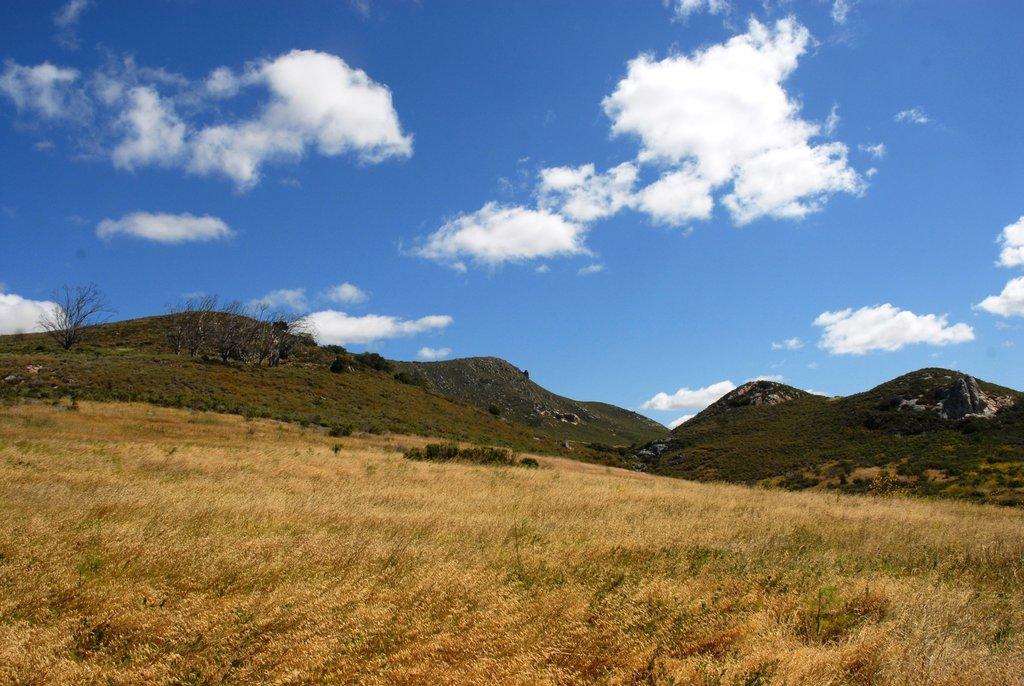Please provide a concise description of this image. It looks like a scenery where there is grass at the bottom. In the middle there are hills. At the top there is the sky. 